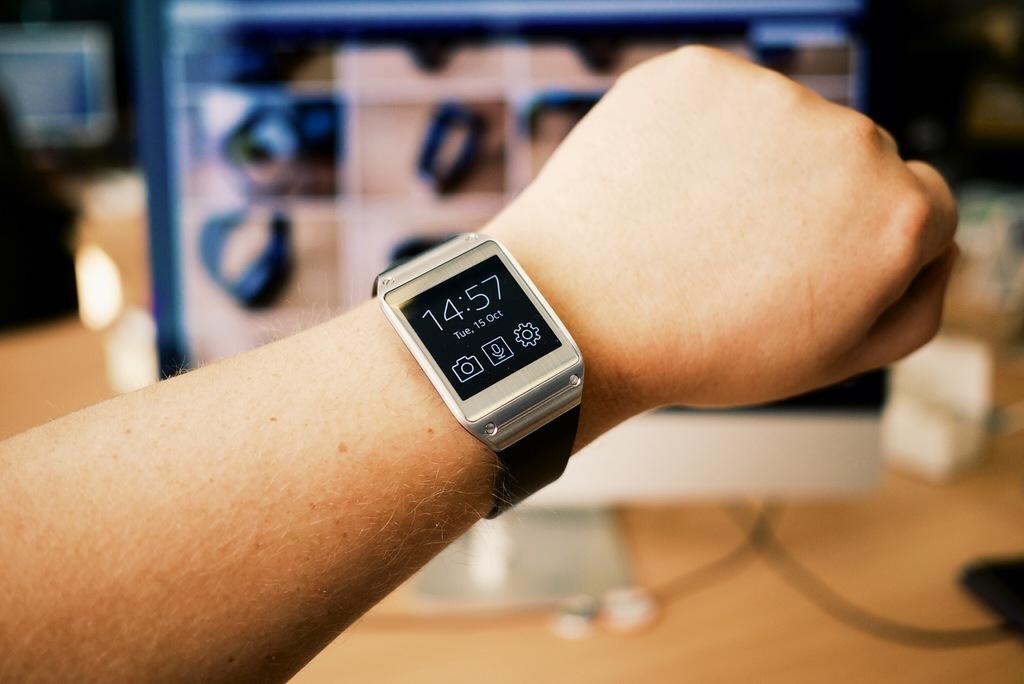What time is shown on the watch?
Offer a terse response. 14:57. What month does it say on the watch?
Ensure brevity in your answer.  October. 